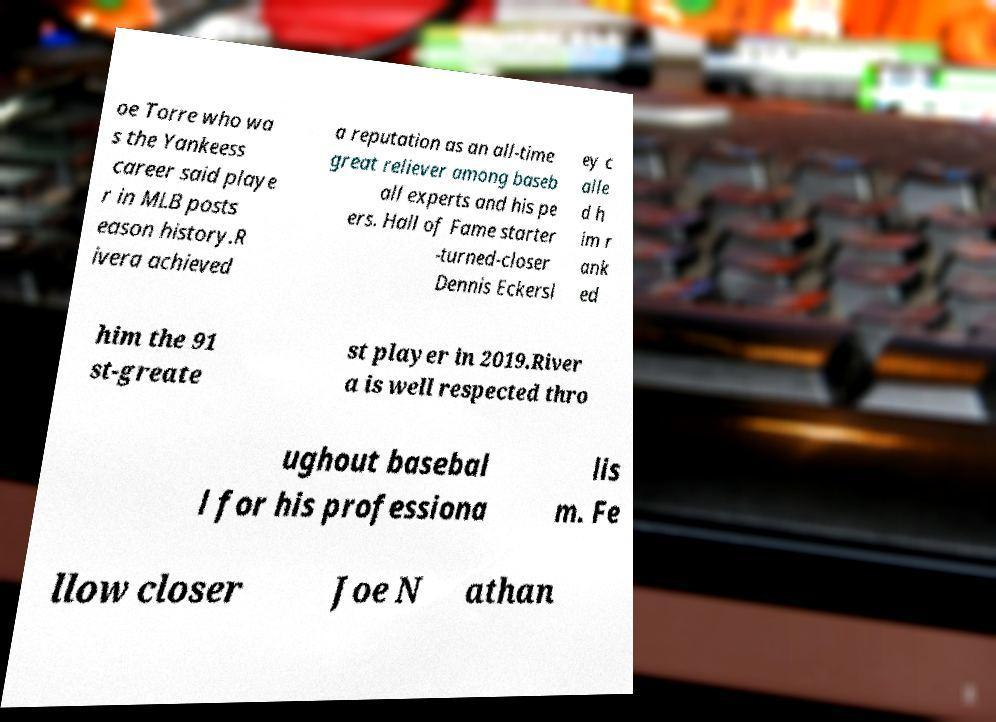Please identify and transcribe the text found in this image. oe Torre who wa s the Yankeess career said playe r in MLB posts eason history.R ivera achieved a reputation as an all-time great reliever among baseb all experts and his pe ers. Hall of Fame starter -turned-closer Dennis Eckersl ey c alle d h im r ank ed him the 91 st-greate st player in 2019.River a is well respected thro ughout basebal l for his professiona lis m. Fe llow closer Joe N athan 